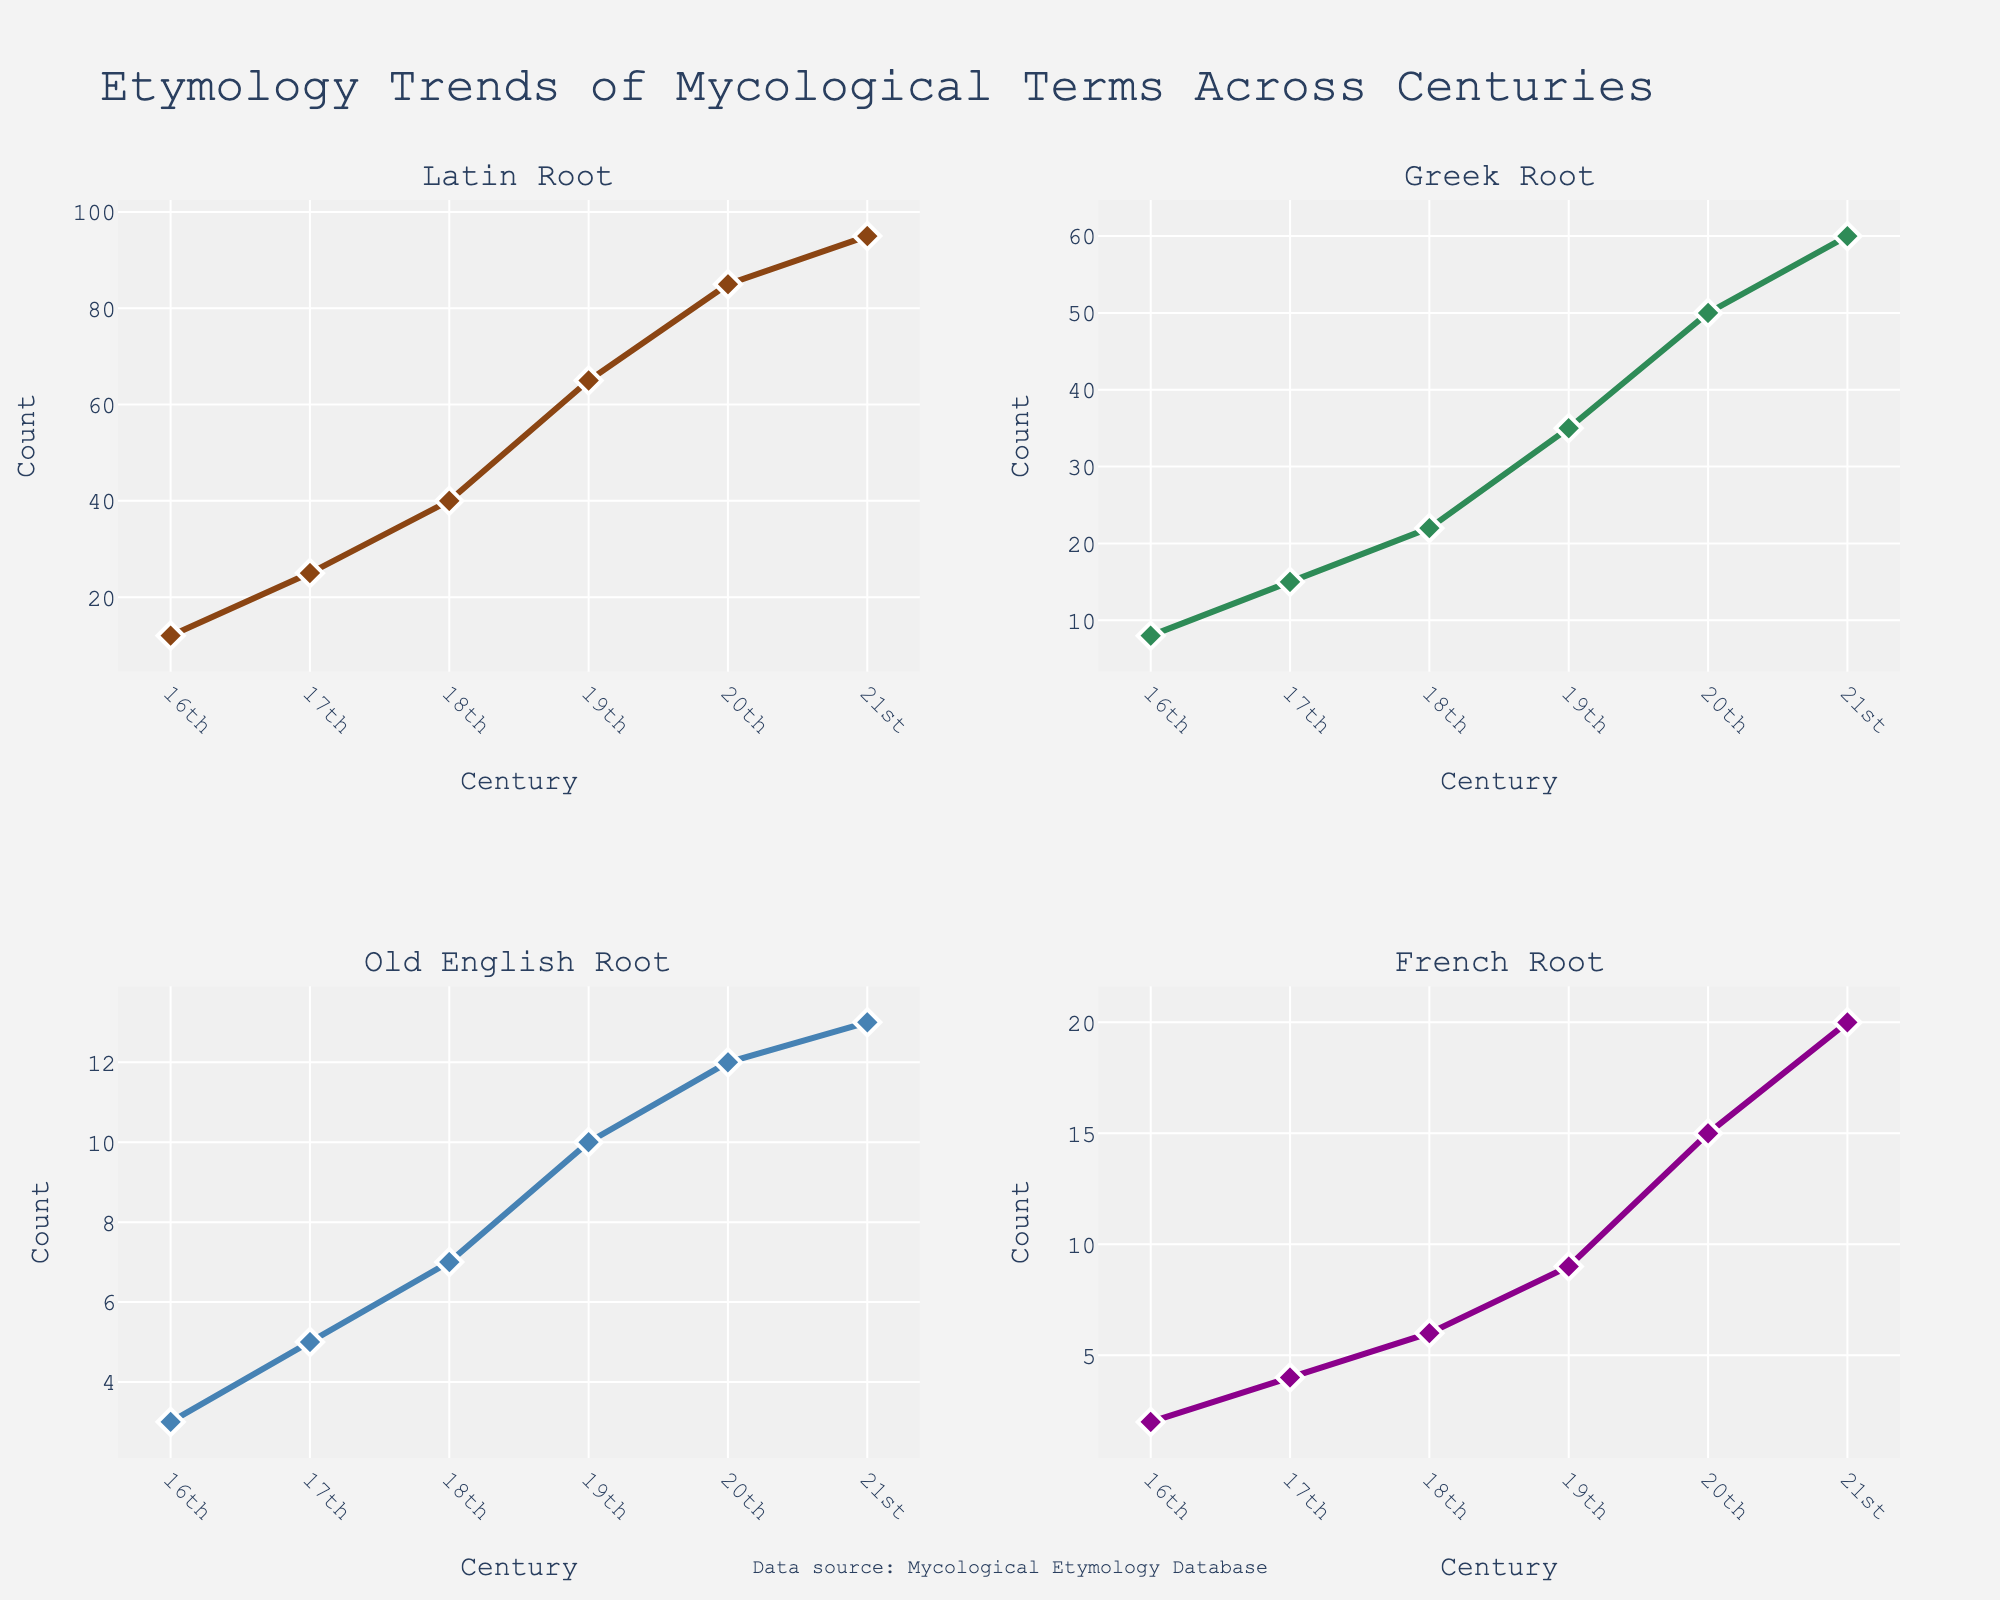What is the title of the plot? The title of the plot is prominently displayed at the top of the figure. It is written in large font for visibility.
Answer: Household Budget Allocation During Life Transitions How many data points are represented in the scatterplot matrix? Count the number of unique symbols or markers present in the scatterplot matrix for all the plots. Each symbol represents a data point.
Answer: 16 Which transition stage has the highest average spending on luxuries? To determine this, look at the Luxuries column and compare the average spending across different transition stages (Early, Mid, Late, Post). Calculate the average for each stage and compare them.
Answer: Post What is the relationship between income and savings in the Mid transition stage? By visually inspecting the scatterplot that compares income and savings, observe the trend of data points marked for the Mid transition stage. Check whether the data points suggest an increasing or decreasing trend.
Answer: Positive correlation Which transition stage shows the most significant increase in spending on essentials compared to the Early stage? Compare the increase in spending on essentials from the Early stage to the other stages (Mid, Late, Post). Subtract the values and find the largest difference.
Answer: Post Is there a noticeable difference in spending on luxuries between the Early and Late transition stages? Compare the data points corresponding to the Early and Late transition stages in the Luxuries dimension. Look for overlapping or separate clusters indicating the differences in spending.
Answer: Yes How does spending on essentials vary with income across the different transition stages? Observe the scatterplots comparing income and essentials for each transition stage. Look for patterns or trends in how spending on essentials changes with varying income levels across stages.
Answer: Varies but generally increases Are there any outliers in the data points for the Late transition stage? Examine the data points marked for the Late transition stage across the plots. Identify any points that significantly deviate from the general trend or cluster.
Answer: No significant outliers What does the scatterplot matrix reveal about the relationship between savings and income across different transition stages? Look at all the scatterplots displaying the relationship between income and savings. Compare the trends across different transition stages to identify common patterns or differences.
Answer: Higher income leads to higher savings Which two categories have the most similar trends across different income levels? Compare the scatterplots of various categories (Essentials, Luxuries, Savings) against Income. Identify which two categories have data points that follow similar trends (e.g., both increasing or decreasing with income).
Answer: Essentials and Savings 